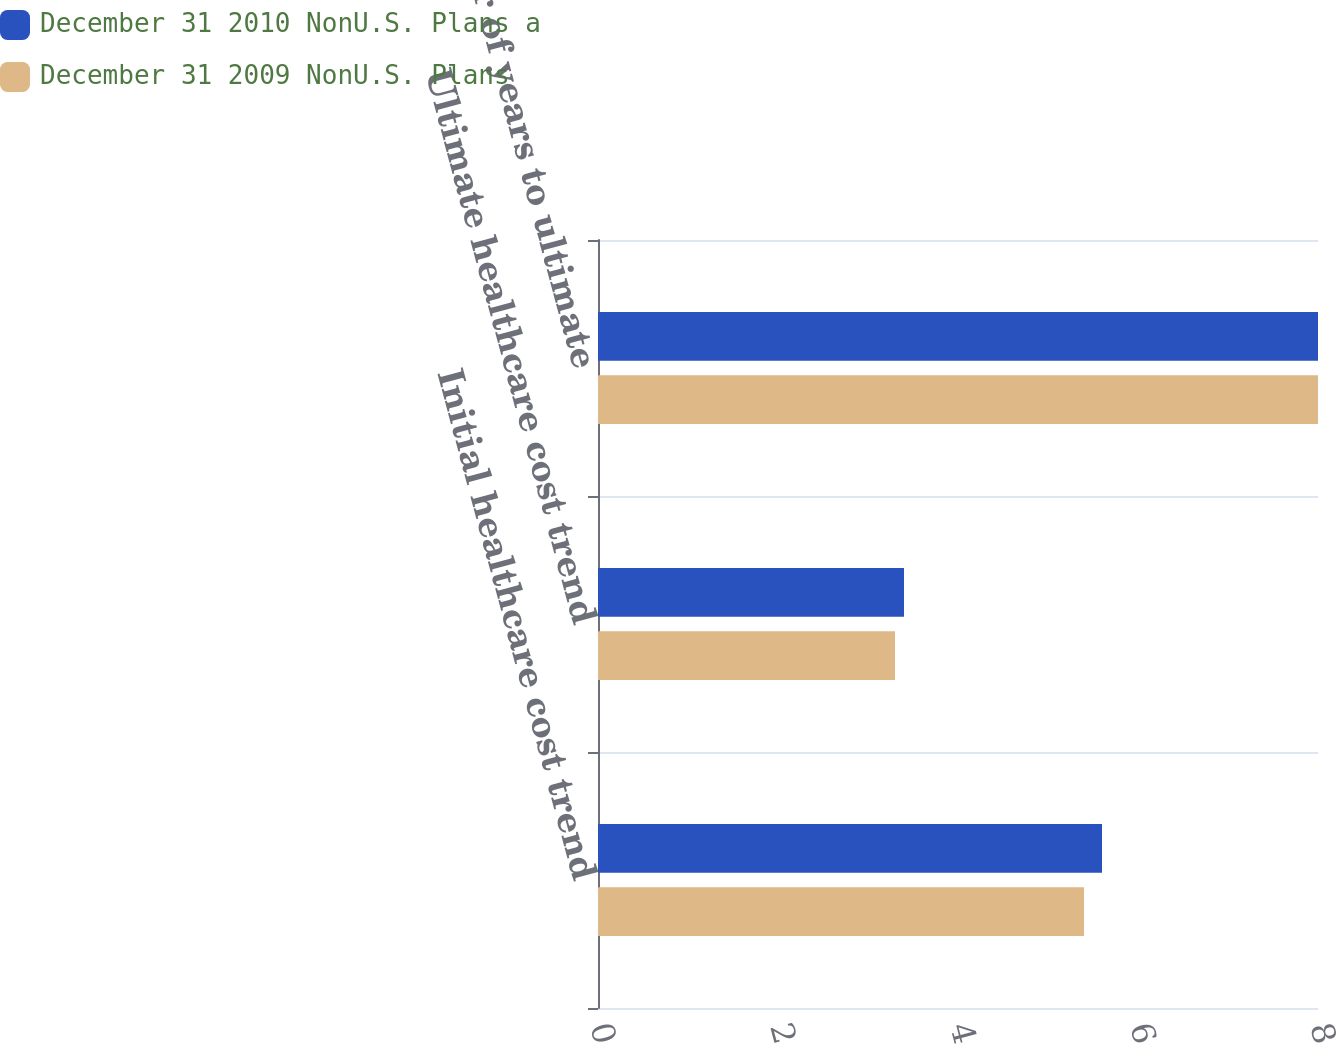Convert chart. <chart><loc_0><loc_0><loc_500><loc_500><stacked_bar_chart><ecel><fcel>Initial healthcare cost trend<fcel>Ultimate healthcare cost trend<fcel>Number of years to ultimate<nl><fcel>December 31 2010 NonU.S. Plans a<fcel>5.6<fcel>3.4<fcel>8<nl><fcel>December 31 2009 NonU.S. Plans<fcel>5.4<fcel>3.3<fcel>8<nl></chart> 